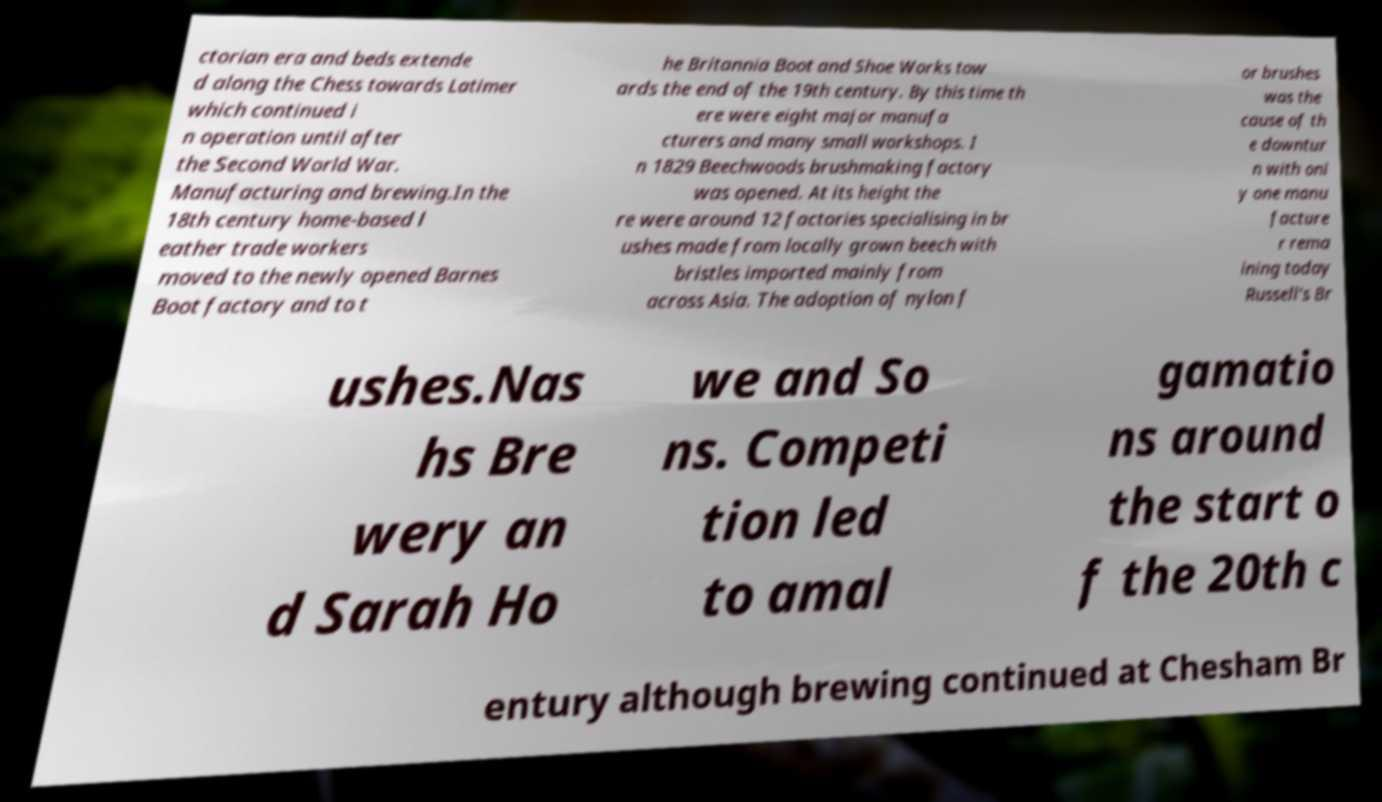Can you read and provide the text displayed in the image?This photo seems to have some interesting text. Can you extract and type it out for me? ctorian era and beds extende d along the Chess towards Latimer which continued i n operation until after the Second World War. Manufacturing and brewing.In the 18th century home-based l eather trade workers moved to the newly opened Barnes Boot factory and to t he Britannia Boot and Shoe Works tow ards the end of the 19th century. By this time th ere were eight major manufa cturers and many small workshops. I n 1829 Beechwoods brushmaking factory was opened. At its height the re were around 12 factories specialising in br ushes made from locally grown beech with bristles imported mainly from across Asia. The adoption of nylon f or brushes was the cause of th e downtur n with onl y one manu facture r rema ining today Russell's Br ushes.Nas hs Bre wery an d Sarah Ho we and So ns. Competi tion led to amal gamatio ns around the start o f the 20th c entury although brewing continued at Chesham Br 